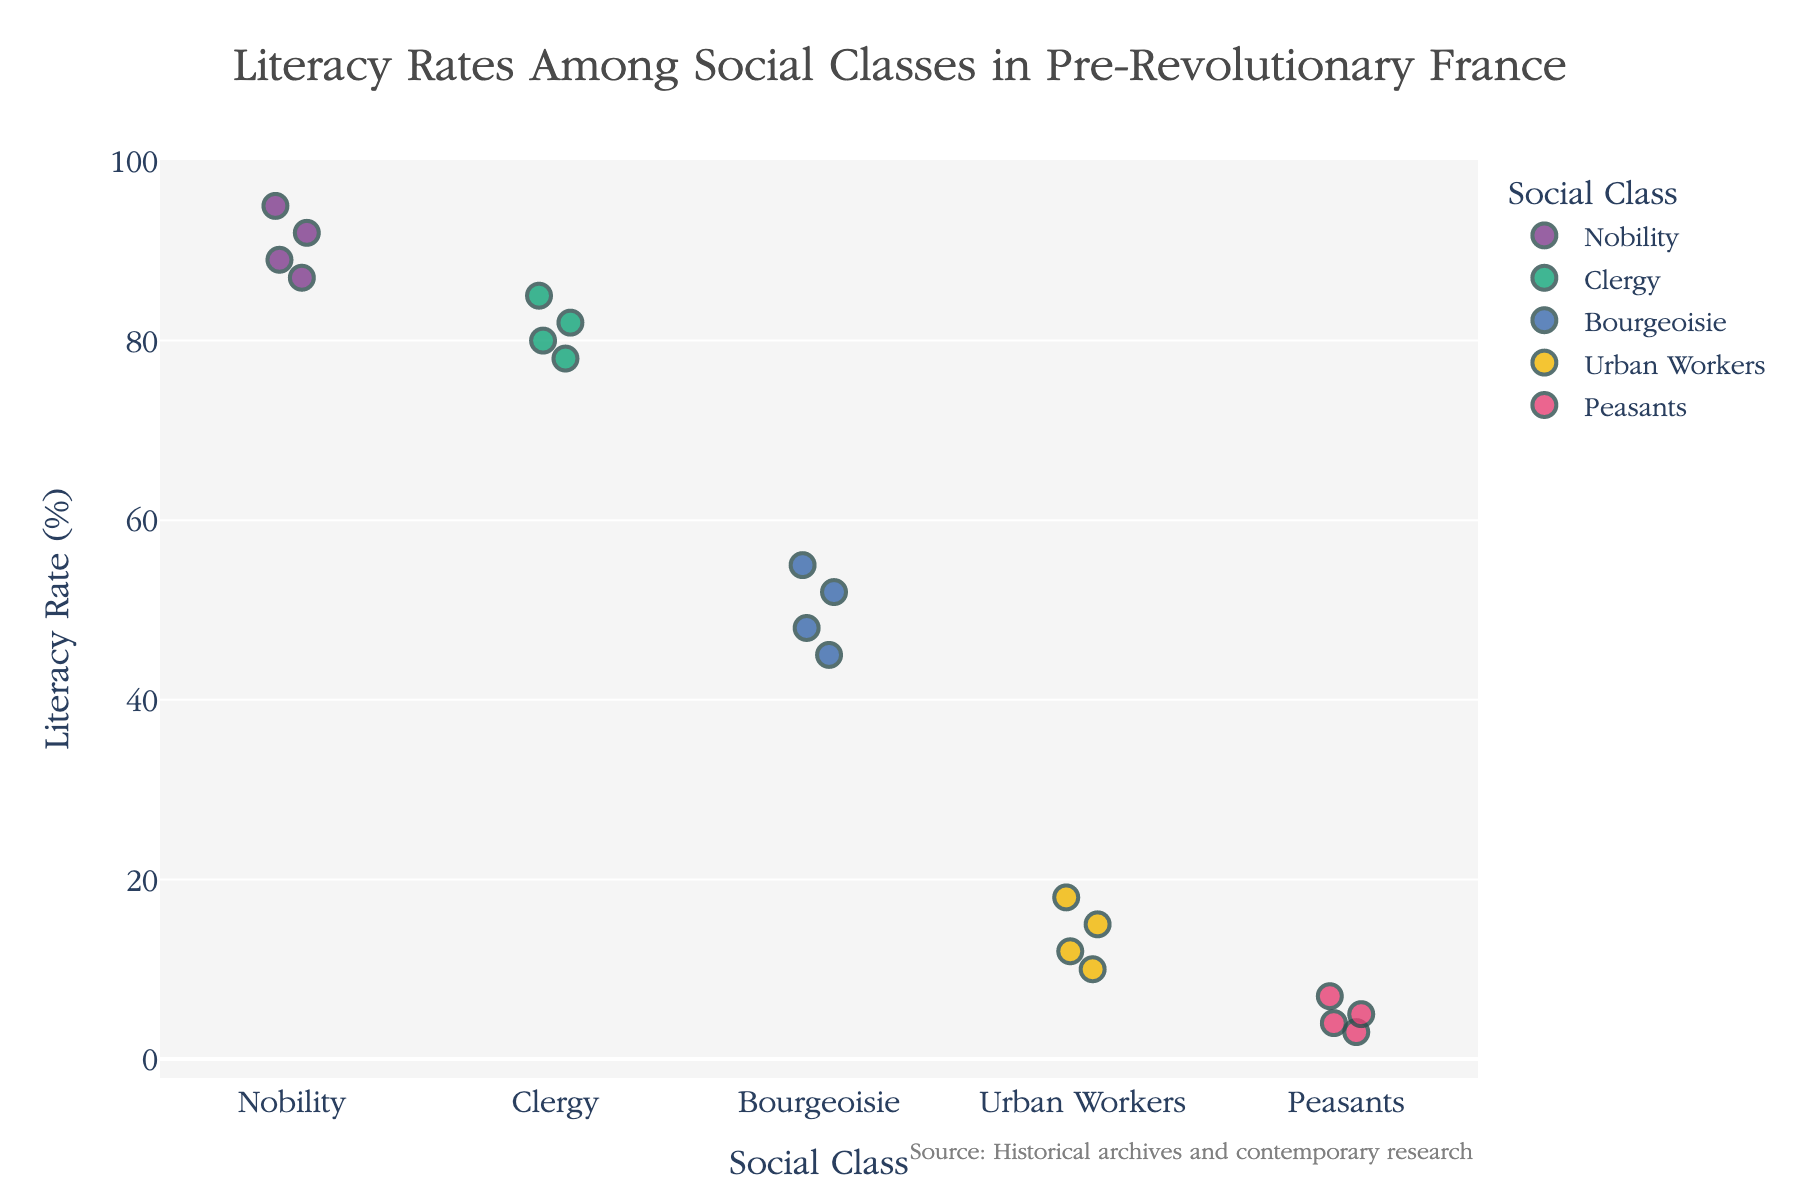What is the title of the figure? The title of a figure is typically located at the top and is clearly visible. The provided data and code specify the title as "Literacy Rates Among Social Classes in Pre-Revolutionary France."
Answer: Literacy Rates Among Social Classes in Pre-Revolutionary France How many social classes are depicted in the plot? The x-axis usually categorizes different groups. In this case, the x-axis shows the social classes: Nobility, Clergy, Bourgeoisie, Urban Workers, and Peasants. Counting these, there are five social classes.
Answer: 5 What is the highest literacy rate observed among the Nobility? The y-axis indicates the literacy rate, and by examining the points plotted for the Nobility, we can identify the highest rate among them. The highest literacy rate is 95%.
Answer: 95% Which social class has the lowest overall literacy rate? By examining the y-axis values for each social class, it's evident that the Peasants have the lowest literacy rates, falling between 3% and 7%.
Answer: Peasants What is the median literacy rate for the Bourgeoisie? To find the median, arrange the literacy rates of the Bourgeoisie (45, 48, 52, 55) in ascending order. Since there is an even number of data points, the median is the average of the middle two numbers (48 + 52) / 2.0 = 50.
Answer: 50 How do the literacy rates of the Clergy compare to those of the Bourgeoisie? The Clergy have literacy rates ranging from 78 to 85, while the Bourgeoisie range from 45 to 55. By comparing these ranges, it is clear that the Clergy's literacy rates are consistently higher than those of the Bourgeoisie.
Answer: Clergy > Bourgeoisie What is the average literacy rate of the Urban Workers? To find the average, sum the literacy rates for Urban Workers (12, 15, 18, 10) and divide by the number of observations. (12 + 15 + 18 + 10) / 4 = 55 / 4 = 13.75.
Answer: 13.75 Which social class shows the greatest variation in literacy rates? By observing the spread (range of y-axis values) for each social class, the Bourgeoisie have rates from 45 to 55 (a range of 10), and the Clergy have rates from 78 to 85 (a range of 7). The Nobility has the greatest deviation from 87 to 95 (a range of 8).
Answer: Bourgeoisie Between which two social classes is the disparity in literacy rates most pronounced? Comparing the ranges visually, the Nobility and Peasants show the greatest disparity, as the Nobility's rates range from 87 to 95, whereas the Peasants' range from 3 to 7.
Answer: Nobility and Peasants What is the lowest literacy rate observed among the Urban Workers? Looking at the y-axis values for the Urban Workers, the lowest rate observed is 10%.
Answer: 10% 